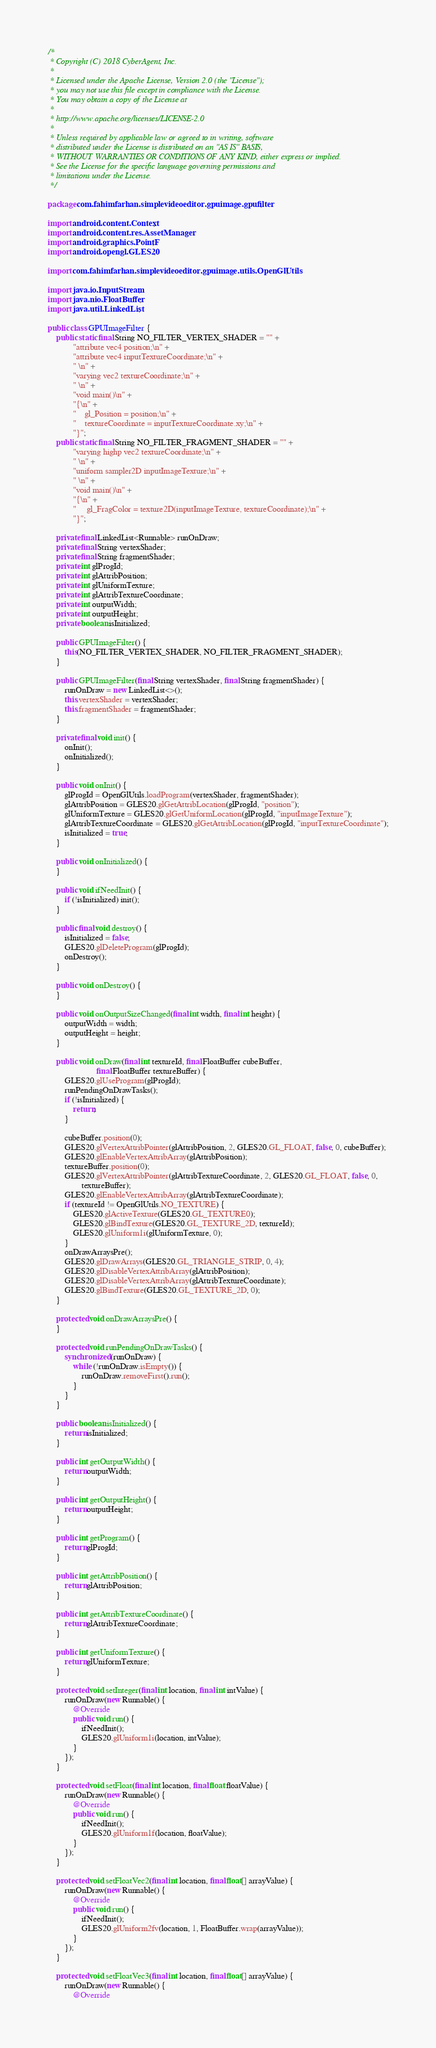<code> <loc_0><loc_0><loc_500><loc_500><_Java_>/*
 * Copyright (C) 2018 CyberAgent, Inc.
 *
 * Licensed under the Apache License, Version 2.0 (the "License");
 * you may not use this file except in compliance with the License.
 * You may obtain a copy of the License at
 *
 * http://www.apache.org/licenses/LICENSE-2.0
 *
 * Unless required by applicable law or agreed to in writing, software
 * distributed under the License is distributed on an "AS IS" BASIS,
 * WITHOUT WARRANTIES OR CONDITIONS OF ANY KIND, either express or implied.
 * See the License for the specific language governing permissions and
 * limitations under the License.
 */

package com.fahimfarhan.simplevideoeditor.gpuimage.gpufilter;

import android.content.Context;
import android.content.res.AssetManager;
import android.graphics.PointF;
import android.opengl.GLES20;

import com.fahimfarhan.simplevideoeditor.gpuimage.utils.OpenGlUtils;

import java.io.InputStream;
import java.nio.FloatBuffer;
import java.util.LinkedList;

public class GPUImageFilter {
    public static final String NO_FILTER_VERTEX_SHADER = "" +
            "attribute vec4 position;\n" +
            "attribute vec4 inputTextureCoordinate;\n" +
            " \n" +
            "varying vec2 textureCoordinate;\n" +
            " \n" +
            "void main()\n" +
            "{\n" +
            "    gl_Position = position;\n" +
            "    textureCoordinate = inputTextureCoordinate.xy;\n" +
            "}";
    public static final String NO_FILTER_FRAGMENT_SHADER = "" +
            "varying highp vec2 textureCoordinate;\n" +
            " \n" +
            "uniform sampler2D inputImageTexture;\n" +
            " \n" +
            "void main()\n" +
            "{\n" +
            "     gl_FragColor = texture2D(inputImageTexture, textureCoordinate);\n" +
            "}";

    private final LinkedList<Runnable> runOnDraw;
    private final String vertexShader;
    private final String fragmentShader;
    private int glProgId;
    private int glAttribPosition;
    private int glUniformTexture;
    private int glAttribTextureCoordinate;
    private int outputWidth;
    private int outputHeight;
    private boolean isInitialized;

    public GPUImageFilter() {
        this(NO_FILTER_VERTEX_SHADER, NO_FILTER_FRAGMENT_SHADER);
    }

    public GPUImageFilter(final String vertexShader, final String fragmentShader) {
        runOnDraw = new LinkedList<>();
        this.vertexShader = vertexShader;
        this.fragmentShader = fragmentShader;
    }

    private final void init() {
        onInit();
        onInitialized();
    }

    public void onInit() {
        glProgId = OpenGlUtils.loadProgram(vertexShader, fragmentShader);
        glAttribPosition = GLES20.glGetAttribLocation(glProgId, "position");
        glUniformTexture = GLES20.glGetUniformLocation(glProgId, "inputImageTexture");
        glAttribTextureCoordinate = GLES20.glGetAttribLocation(glProgId, "inputTextureCoordinate");
        isInitialized = true;
    }

    public void onInitialized() {
    }

    public void ifNeedInit() {
        if (!isInitialized) init();
    }

    public final void destroy() {
        isInitialized = false;
        GLES20.glDeleteProgram(glProgId);
        onDestroy();
    }

    public void onDestroy() {
    }

    public void onOutputSizeChanged(final int width, final int height) {
        outputWidth = width;
        outputHeight = height;
    }

    public void onDraw(final int textureId, final FloatBuffer cubeBuffer,
                       final FloatBuffer textureBuffer) {
        GLES20.glUseProgram(glProgId);
        runPendingOnDrawTasks();
        if (!isInitialized) {
            return;
        }

        cubeBuffer.position(0);
        GLES20.glVertexAttribPointer(glAttribPosition, 2, GLES20.GL_FLOAT, false, 0, cubeBuffer);
        GLES20.glEnableVertexAttribArray(glAttribPosition);
        textureBuffer.position(0);
        GLES20.glVertexAttribPointer(glAttribTextureCoordinate, 2, GLES20.GL_FLOAT, false, 0,
                textureBuffer);
        GLES20.glEnableVertexAttribArray(glAttribTextureCoordinate);
        if (textureId != OpenGlUtils.NO_TEXTURE) {
            GLES20.glActiveTexture(GLES20.GL_TEXTURE0);
            GLES20.glBindTexture(GLES20.GL_TEXTURE_2D, textureId);
            GLES20.glUniform1i(glUniformTexture, 0);
        }
        onDrawArraysPre();
        GLES20.glDrawArrays(GLES20.GL_TRIANGLE_STRIP, 0, 4);
        GLES20.glDisableVertexAttribArray(glAttribPosition);
        GLES20.glDisableVertexAttribArray(glAttribTextureCoordinate);
        GLES20.glBindTexture(GLES20.GL_TEXTURE_2D, 0);
    }

    protected void onDrawArraysPre() {
    }

    protected void runPendingOnDrawTasks() {
        synchronized (runOnDraw) {
            while (!runOnDraw.isEmpty()) {
                runOnDraw.removeFirst().run();
            }
        }
    }

    public boolean isInitialized() {
        return isInitialized;
    }

    public int getOutputWidth() {
        return outputWidth;
    }

    public int getOutputHeight() {
        return outputHeight;
    }

    public int getProgram() {
        return glProgId;
    }

    public int getAttribPosition() {
        return glAttribPosition;
    }

    public int getAttribTextureCoordinate() {
        return glAttribTextureCoordinate;
    }

    public int getUniformTexture() {
        return glUniformTexture;
    }

    protected void setInteger(final int location, final int intValue) {
        runOnDraw(new Runnable() {
            @Override
            public void run() {
                ifNeedInit();
                GLES20.glUniform1i(location, intValue);
            }
        });
    }

    protected void setFloat(final int location, final float floatValue) {
        runOnDraw(new Runnable() {
            @Override
            public void run() {
                ifNeedInit();
                GLES20.glUniform1f(location, floatValue);
            }
        });
    }

    protected void setFloatVec2(final int location, final float[] arrayValue) {
        runOnDraw(new Runnable() {
            @Override
            public void run() {
                ifNeedInit();
                GLES20.glUniform2fv(location, 1, FloatBuffer.wrap(arrayValue));
            }
        });
    }

    protected void setFloatVec3(final int location, final float[] arrayValue) {
        runOnDraw(new Runnable() {
            @Override</code> 